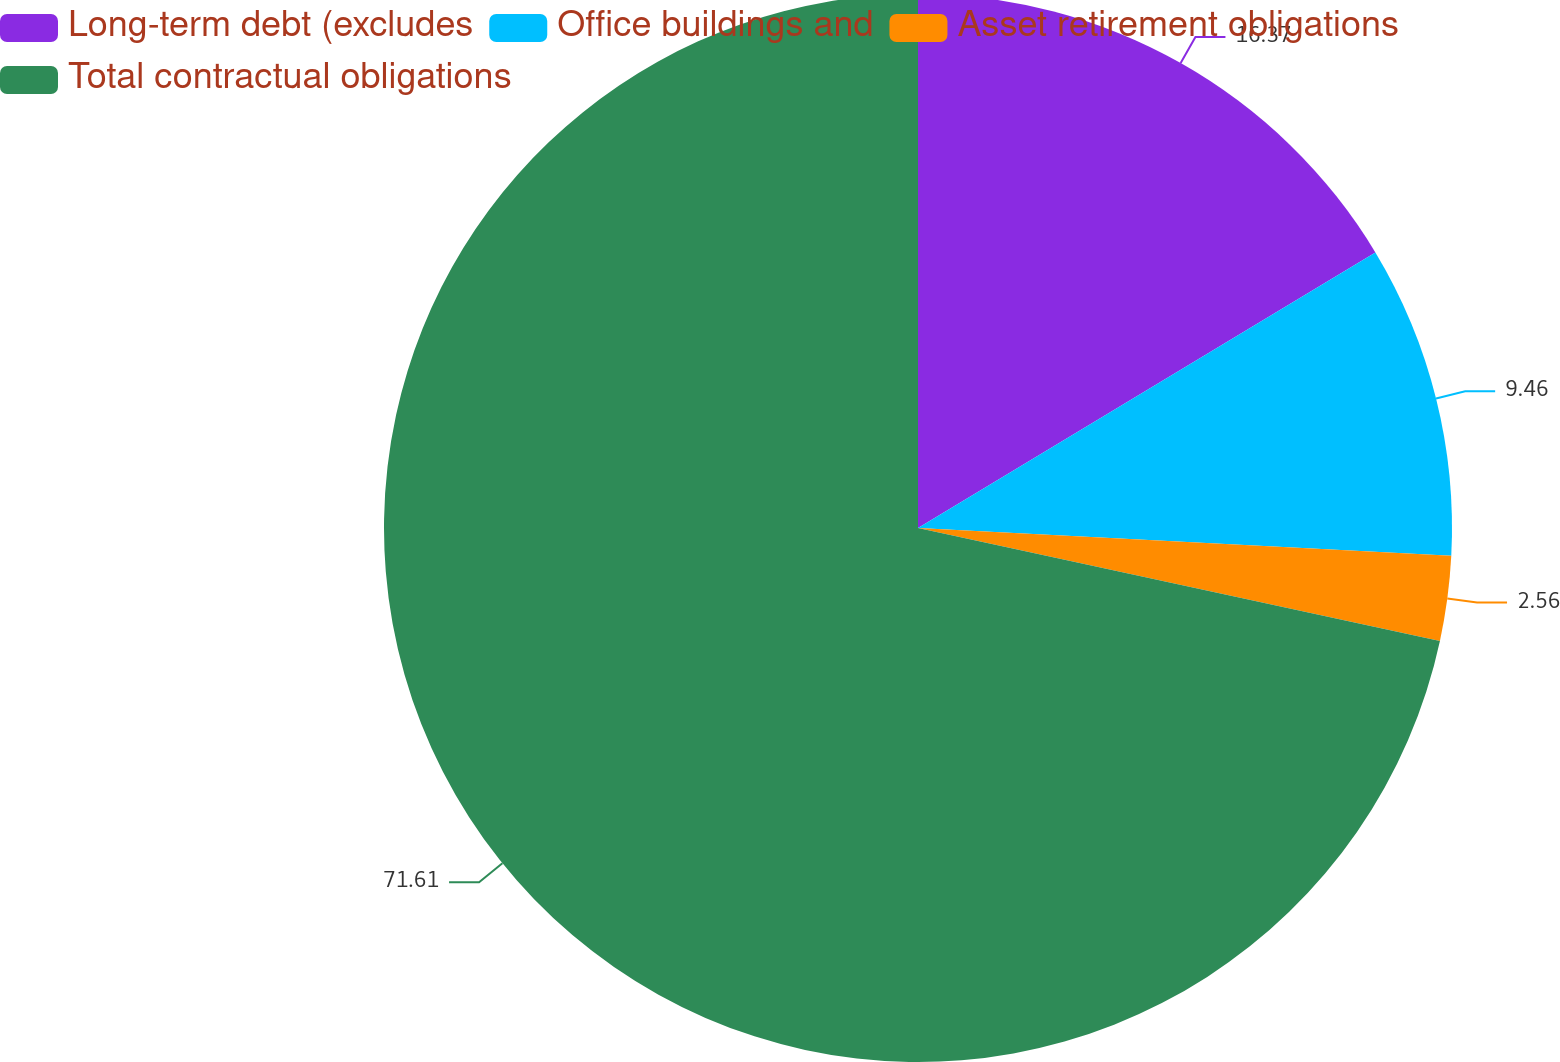Convert chart to OTSL. <chart><loc_0><loc_0><loc_500><loc_500><pie_chart><fcel>Long-term debt (excludes<fcel>Office buildings and<fcel>Asset retirement obligations<fcel>Total contractual obligations<nl><fcel>16.37%<fcel>9.46%<fcel>2.56%<fcel>71.61%<nl></chart> 